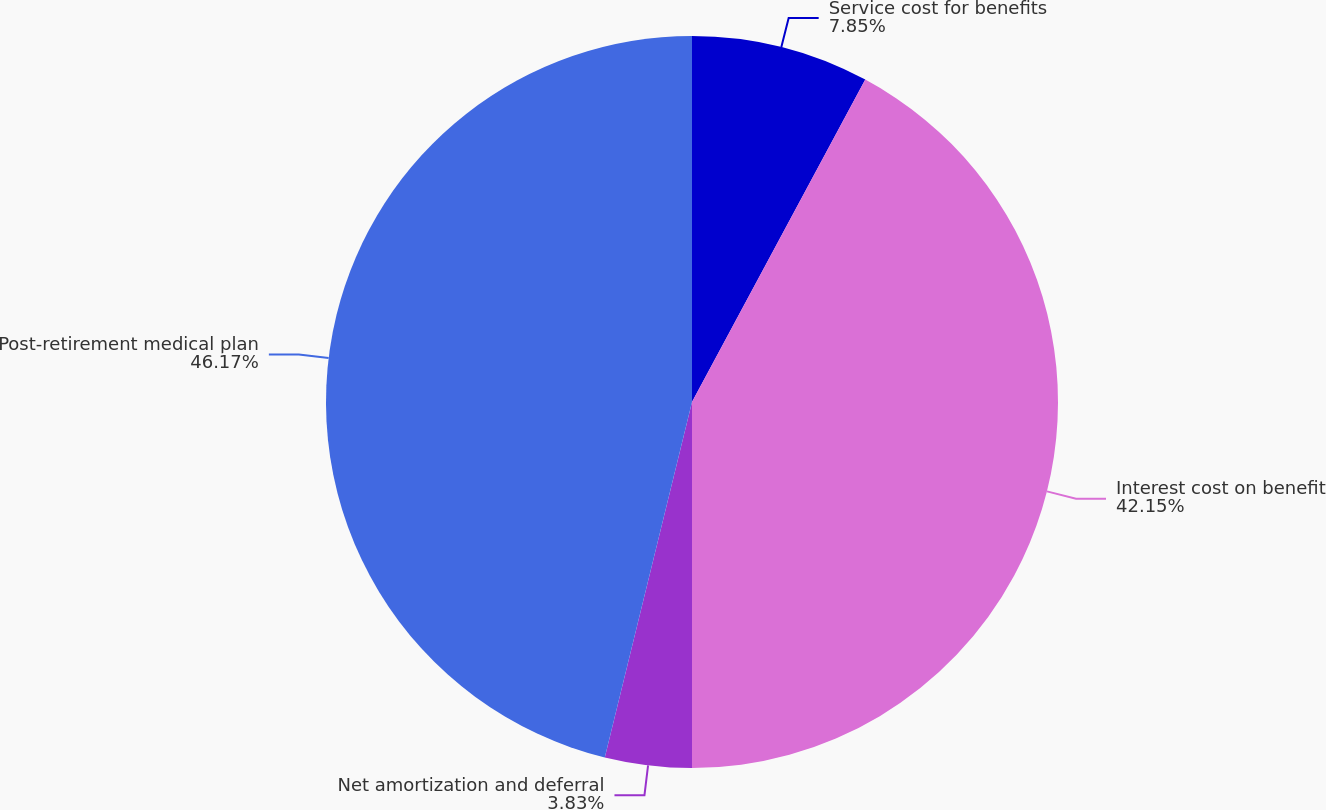Convert chart. <chart><loc_0><loc_0><loc_500><loc_500><pie_chart><fcel>Service cost for benefits<fcel>Interest cost on benefit<fcel>Net amortization and deferral<fcel>Post-retirement medical plan<nl><fcel>7.85%<fcel>42.15%<fcel>3.83%<fcel>46.17%<nl></chart> 